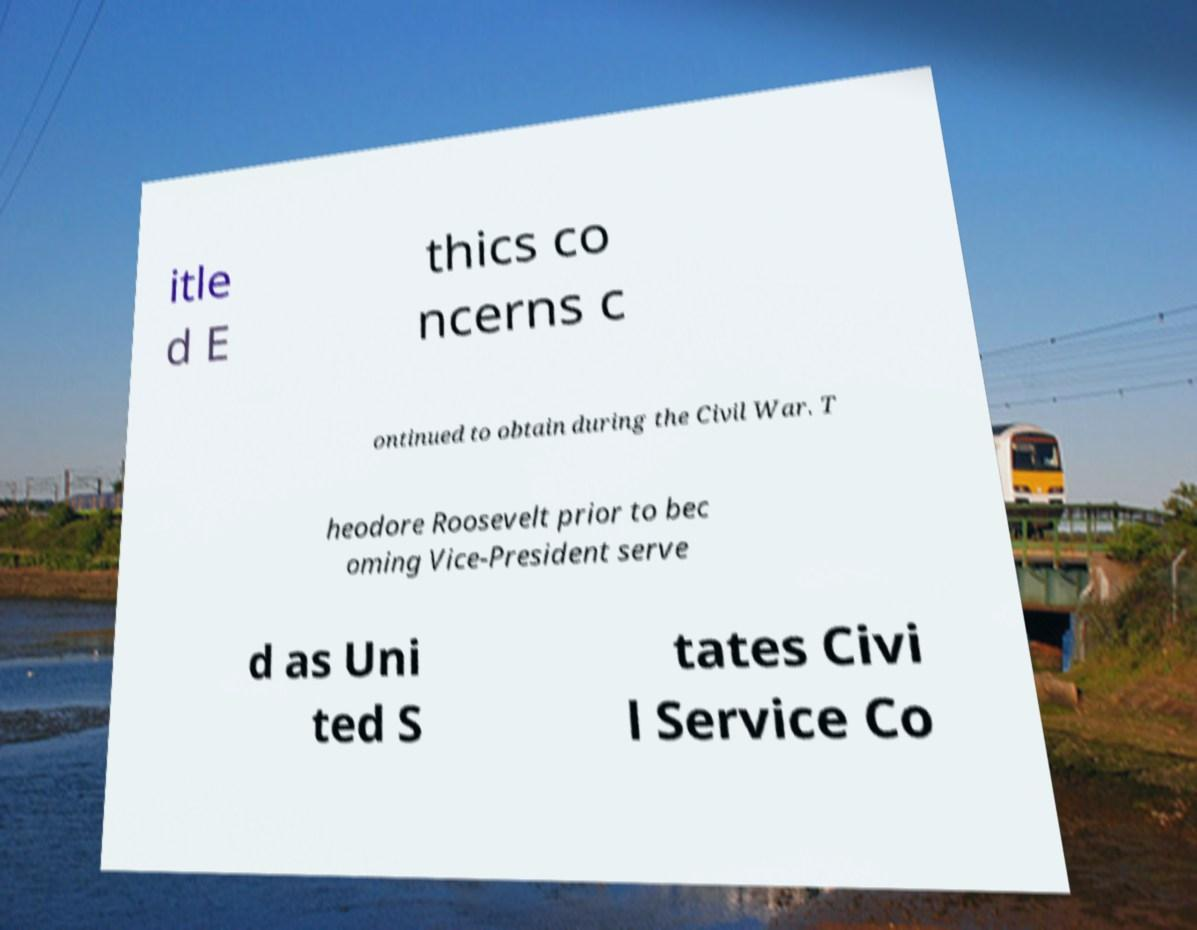Can you read and provide the text displayed in the image?This photo seems to have some interesting text. Can you extract and type it out for me? itle d E thics co ncerns c ontinued to obtain during the Civil War. T heodore Roosevelt prior to bec oming Vice-President serve d as Uni ted S tates Civi l Service Co 